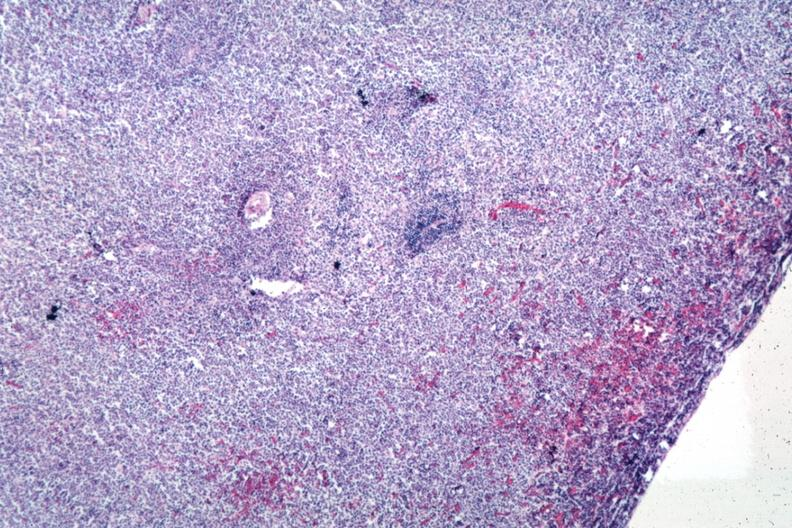s cryptosporidia present?
Answer the question using a single word or phrase. No 